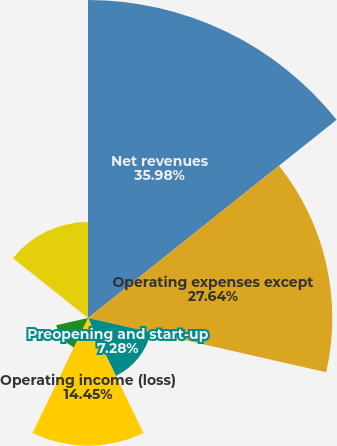Convert chart. <chart><loc_0><loc_0><loc_500><loc_500><pie_chart><fcel>Net revenues<fcel>Operating expenses except<fcel>Preopening and start-up<fcel>Operating income (loss)<fcel>Interest expense<fcel>Other non-operating income<fcel>Net income (loss)<nl><fcel>35.98%<fcel>27.64%<fcel>7.28%<fcel>14.45%<fcel>3.69%<fcel>0.1%<fcel>10.86%<nl></chart> 